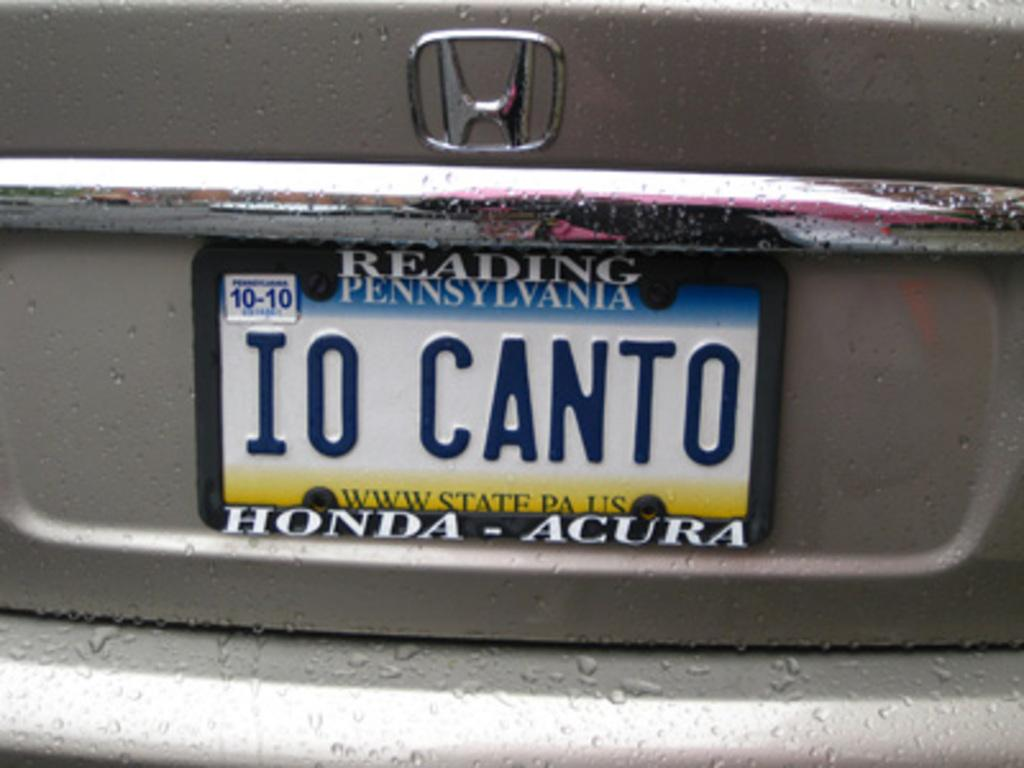Provide a one-sentence caption for the provided image. A Pennsylvania license plate reads IO CANTO and is from Honda. 